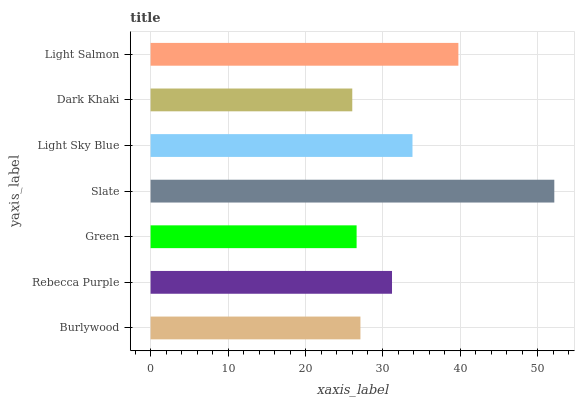Is Dark Khaki the minimum?
Answer yes or no. Yes. Is Slate the maximum?
Answer yes or no. Yes. Is Rebecca Purple the minimum?
Answer yes or no. No. Is Rebecca Purple the maximum?
Answer yes or no. No. Is Rebecca Purple greater than Burlywood?
Answer yes or no. Yes. Is Burlywood less than Rebecca Purple?
Answer yes or no. Yes. Is Burlywood greater than Rebecca Purple?
Answer yes or no. No. Is Rebecca Purple less than Burlywood?
Answer yes or no. No. Is Rebecca Purple the high median?
Answer yes or no. Yes. Is Rebecca Purple the low median?
Answer yes or no. Yes. Is Light Sky Blue the high median?
Answer yes or no. No. Is Green the low median?
Answer yes or no. No. 